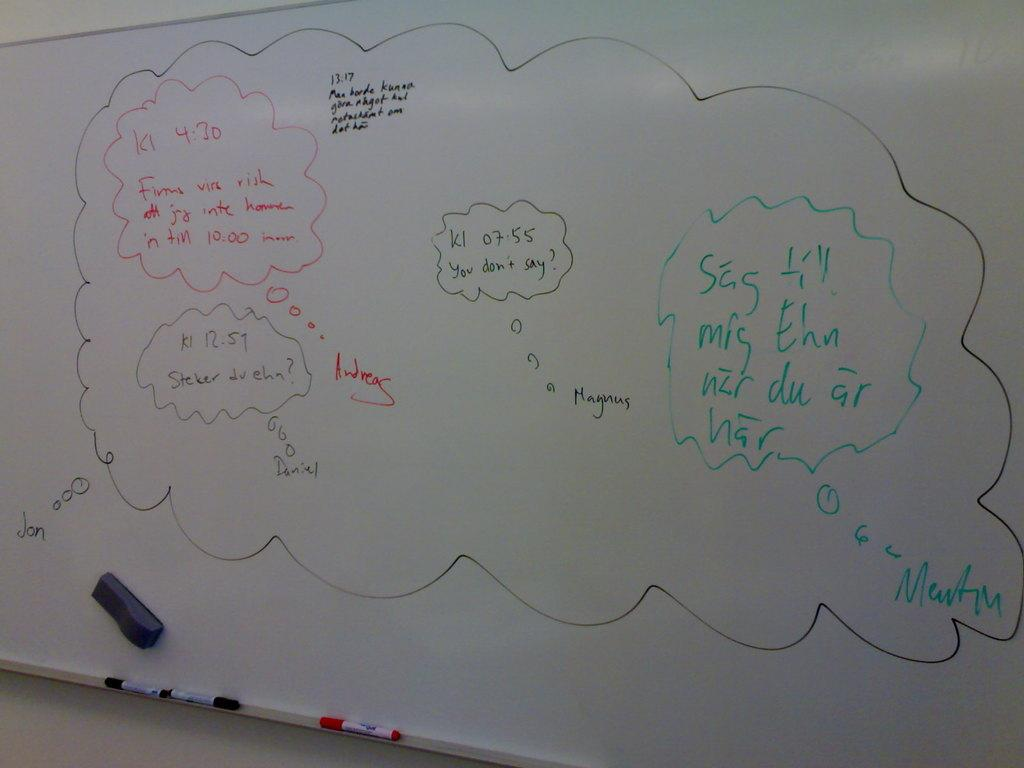Provide a one-sentence caption for the provided image. A white board with several ideas wrote on it including one asking "you don't say". 